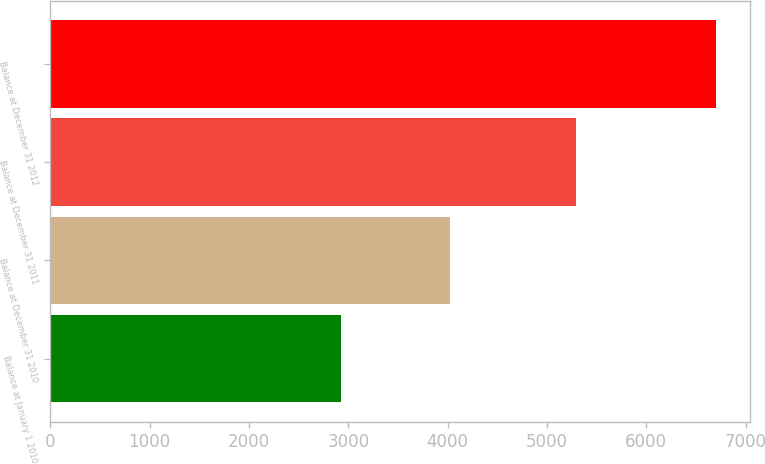Convert chart. <chart><loc_0><loc_0><loc_500><loc_500><bar_chart><fcel>Balance at January 1 2010<fcel>Balance at December 31 2010<fcel>Balance at December 31 2011<fcel>Balance at December 31 2012<nl><fcel>2924<fcel>4027<fcel>5293<fcel>6707<nl></chart> 